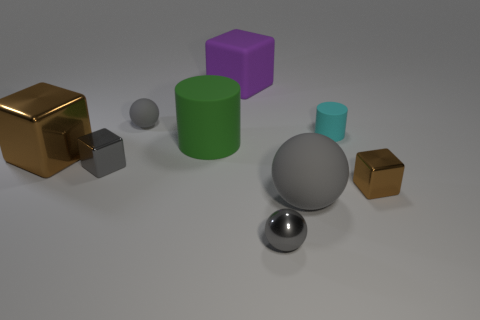What shape is the cyan thing?
Give a very brief answer. Cylinder. Is the large purple cube made of the same material as the brown cube that is left of the large purple rubber block?
Your answer should be compact. No. How many objects are small purple metal cylinders or big brown metal things?
Offer a terse response. 1. Are there any brown matte things?
Provide a succinct answer. No. There is a brown thing that is behind the small gray shiny thing that is behind the tiny brown cube; what is its shape?
Provide a short and direct response. Cube. How many things are shiny blocks that are on the right side of the large shiny block or large gray matte objects that are right of the large green object?
Give a very brief answer. 3. There is a brown thing that is the same size as the gray shiny ball; what is it made of?
Your answer should be very brief. Metal. What color is the big matte cylinder?
Provide a succinct answer. Green. There is a large object that is right of the large brown metallic object and in front of the big green matte cylinder; what is its material?
Offer a terse response. Rubber. There is a purple matte thing that is to the left of the brown block right of the big gray rubber thing; is there a green cylinder that is to the right of it?
Make the answer very short. No. 